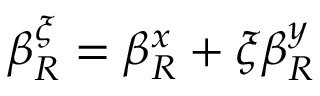Convert formula to latex. <formula><loc_0><loc_0><loc_500><loc_500>\beta _ { R } ^ { \xi } = \beta _ { R } ^ { x } + \xi \beta _ { R } ^ { y }</formula> 